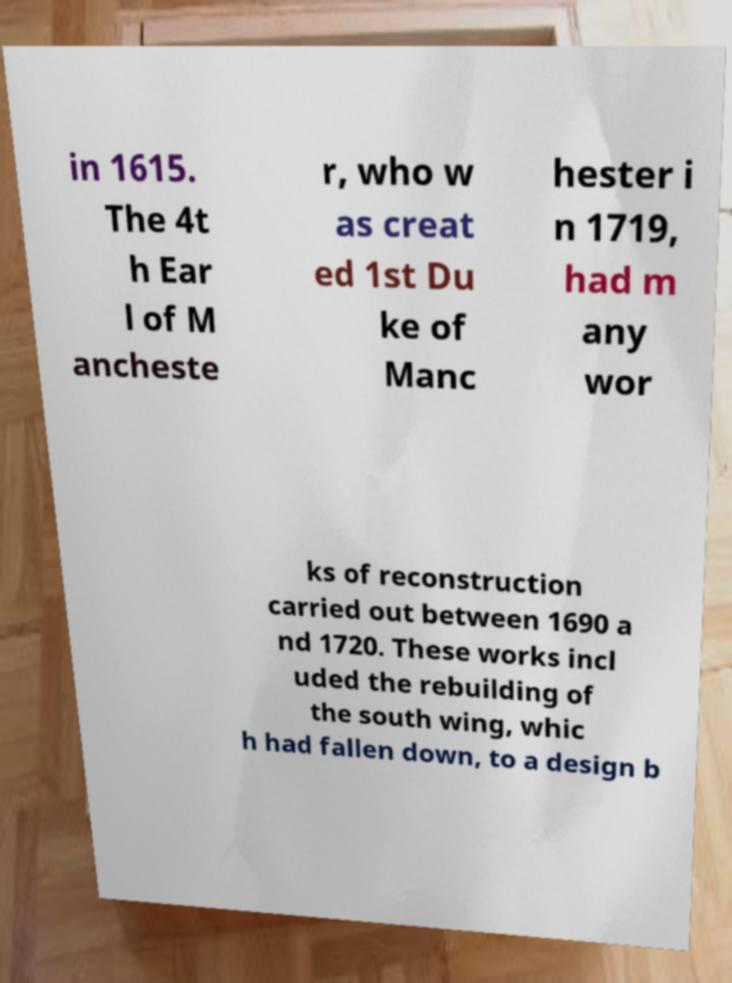There's text embedded in this image that I need extracted. Can you transcribe it verbatim? in 1615. The 4t h Ear l of M ancheste r, who w as creat ed 1st Du ke of Manc hester i n 1719, had m any wor ks of reconstruction carried out between 1690 a nd 1720. These works incl uded the rebuilding of the south wing, whic h had fallen down, to a design b 